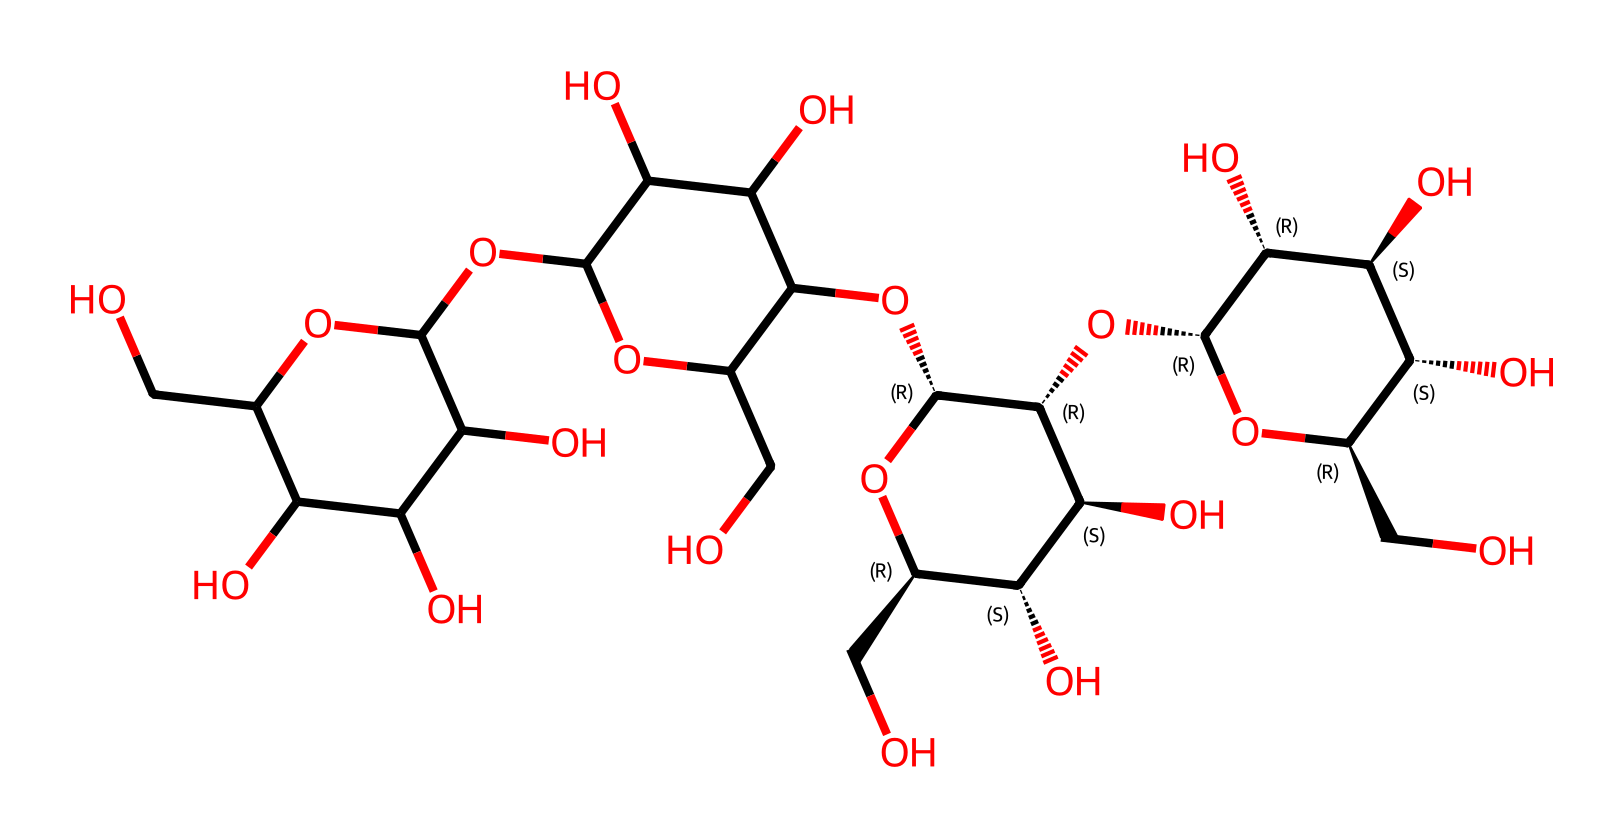What is the primary type of polymer found in this structure? The structure represents starch, which is a polysaccharide composed of glucose units linked together. The branched form of starch is more dominant in the structure due to multiple glycosidic linkages.
Answer: starch How many rings are present in this starch structure? By analyzing the SMILES representation, we can identify the cyclic forms of glucose in starch: there are two distinct rings in this structure that represent the glycosidic bonds forming between them, thus it indicates the presence of two cyclic glucose units.
Answer: 2 What is the significance of the hydroxyl (-OH) groups in this polymer? Hydroxyl groups enhance the solubility of starch in water and contribute to its ability to form hydrogen bonds, which affects the texture and mouthfeel of baked sweet potatoes.
Answer: solubility How many glucose units are represented in this structure? The count of glucose units can be done by identifying the repeating units in the structure. From the visual representation in the SMILES string, there are a total of 9 glucose units represented.
Answer: 9 What type of glycosidic linkage is predominantly present in this starch molecule? The predominant glycosidic linkage in starch is the alpha-1,4-glycosidic bond, which is crucial for the linear and branched arrangements in the structure of starch.
Answer: alpha-1,4-glycosidic bond Which feature in the structure contributes to its digestibility? The presence of alpha-glycosidic bonds contributes to the digestibility of starch, as enzymes in the human digestive system can readily break them down into glucose.
Answer: alpha-glycosidic bonds 